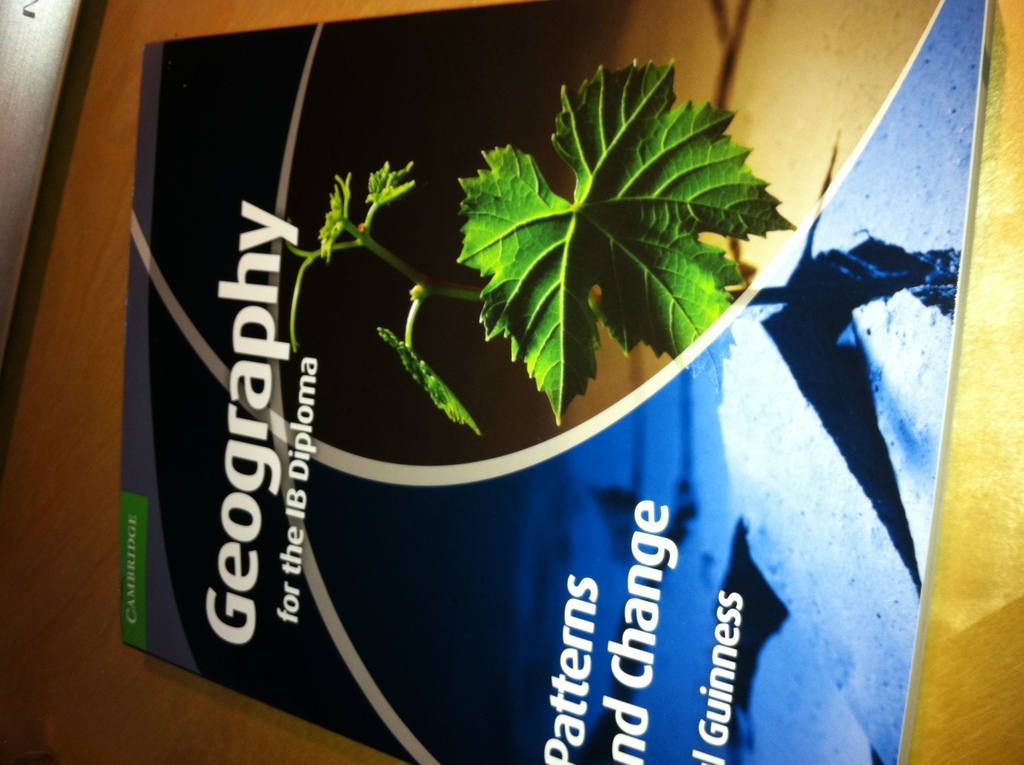Can you explain the significance of the choice of colors used on the book cover? The use of dark and light blues alongside vibrant green on the cover may represent the various elements of geography such as water, vegetation, and the earth, aiming to visually cue readers about the book's comprehensive coverage of different geographical aspects. 